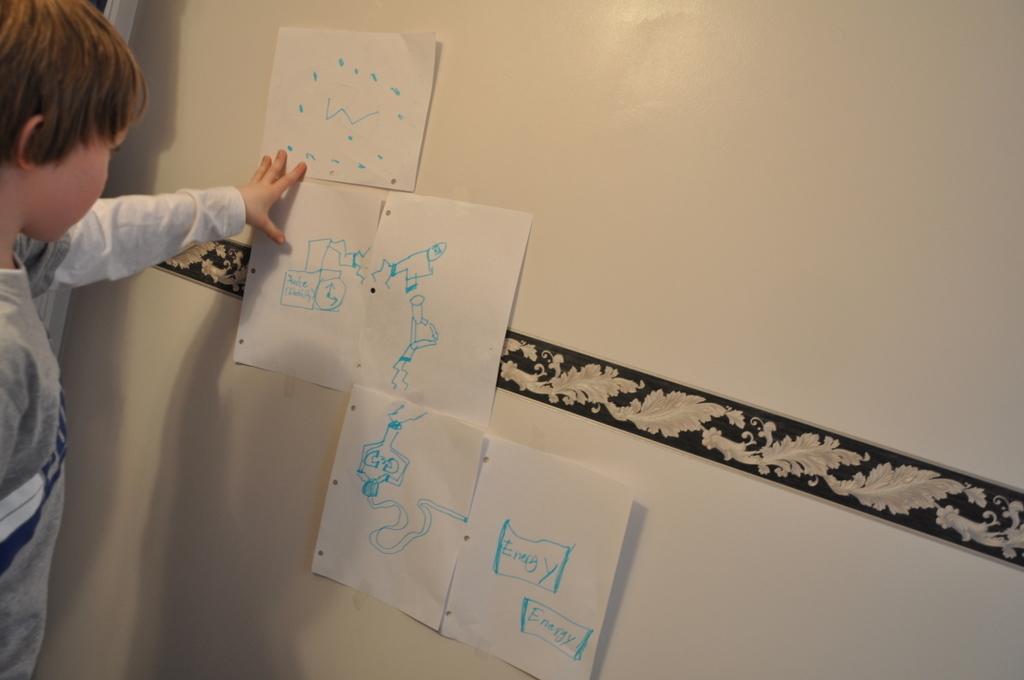What word is written in the blue boxes?
Ensure brevity in your answer.  Energy. 